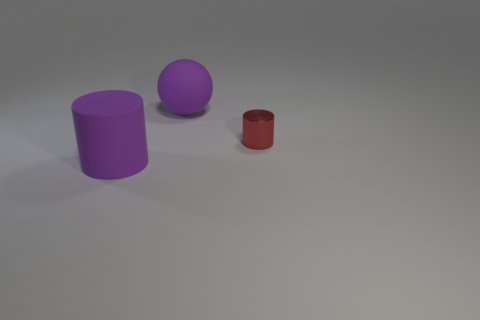What size is the cylinder behind the big purple cylinder?
Give a very brief answer. Small. Are the cylinder on the left side of the red cylinder and the red object made of the same material?
Provide a succinct answer. No. Are there fewer purple balls than big brown things?
Offer a very short reply. No. What is the material of the big purple object that is in front of the purple matte ball behind the cylinder that is behind the matte cylinder?
Your response must be concise. Rubber. What is the material of the big sphere?
Offer a terse response. Rubber. Is the color of the rubber object in front of the small cylinder the same as the rubber thing behind the red metal cylinder?
Ensure brevity in your answer.  Yes. Is the number of tiny things greater than the number of big brown metal blocks?
Your answer should be very brief. Yes. How many big objects have the same color as the large cylinder?
Make the answer very short. 1. There is another rubber thing that is the same shape as the red thing; what is its color?
Provide a short and direct response. Purple. There is a object that is both in front of the purple matte ball and behind the purple matte cylinder; what is its material?
Offer a very short reply. Metal. 